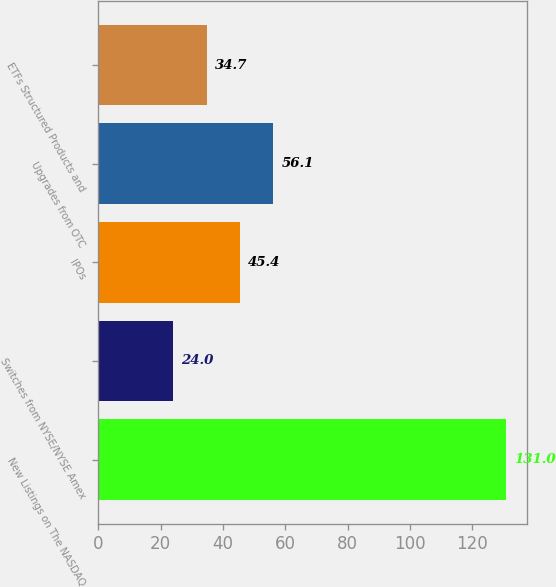<chart> <loc_0><loc_0><loc_500><loc_500><bar_chart><fcel>New Listings on The NASDAQ<fcel>Switches from NYSE/NYSE Amex<fcel>IPOs<fcel>Upgrades from OTC<fcel>ETFs Structured Products and<nl><fcel>131<fcel>24<fcel>45.4<fcel>56.1<fcel>34.7<nl></chart> 